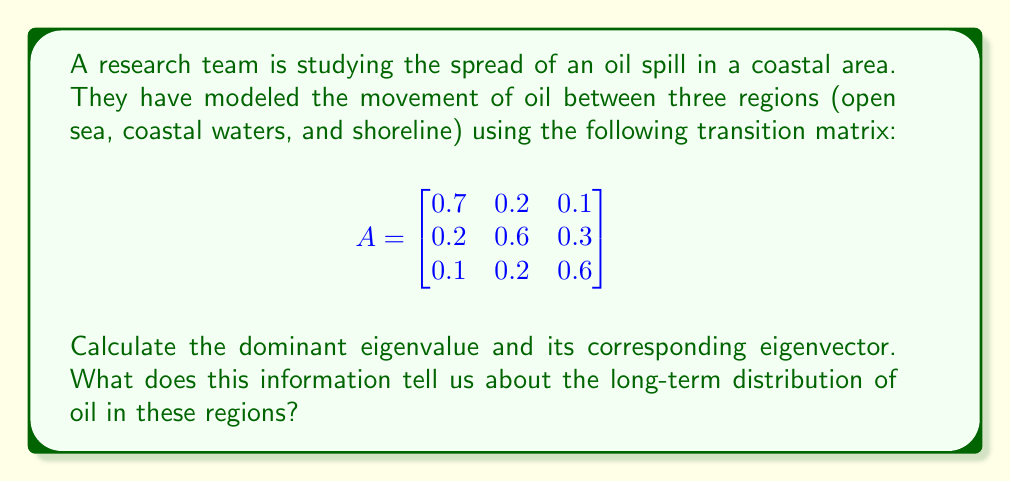Solve this math problem. To solve this problem, we need to follow these steps:

1) Find the characteristic equation:
   $$det(A - \lambda I) = 0$$
   
   $$\begin{vmatrix}
   0.7-\lambda & 0.2 & 0.1 \\
   0.2 & 0.6-\lambda & 0.3 \\
   0.1 & 0.2 & 0.6-\lambda
   \end{vmatrix} = 0$$

2) Expand the determinant:
   $$(0.7-\lambda)(0.6-\lambda)(0.6-\lambda) - 0.2 \cdot 0.3 \cdot 0.1 - 0.1 \cdot 0.2 \cdot 0.2 - (0.7-\lambda) \cdot 0.2 \cdot 0.2 - 0.2 \cdot (0.6-\lambda) \cdot 0.1 - 0.1 \cdot 0.3 \cdot (0.6-\lambda) = 0$$

3) Simplify:
   $$-\lambda^3 + 1.9\lambda^2 - 1.14\lambda + 0.216 = 0$$

4) Solve this cubic equation. The solutions are the eigenvalues. The largest eigenvalue is the dominant eigenvalue:
   $$\lambda_1 = 1, \lambda_2 \approx 0.5, \lambda_3 \approx 0.4$$

   The dominant eigenvalue is 1.

5) Find the eigenvector $v$ corresponding to $\lambda = 1$:
   $$(A - I)v = 0$$

   $$\begin{bmatrix}
   -0.3 & 0.2 & 0.1 \\
   0.2 & -0.4 & 0.3 \\
   0.1 & 0.2 & -0.4
   \end{bmatrix} \begin{bmatrix} v_1 \\ v_2 \\ v_3 \end{bmatrix} = \begin{bmatrix} 0 \\ 0 \\ 0 \end{bmatrix}$$

6) Solve this system of equations. One solution is:
   $$v = \begin{bmatrix} 2 \\ 3 \\ 3 \end{bmatrix}$$

7) Normalize the eigenvector:
   $$v_{normalized} = \frac{1}{\sqrt{2^2 + 3^2 + 3^2}} \begin{bmatrix} 2 \\ 3 \\ 3 \end{bmatrix} = \begin{bmatrix} 0.25 \\ 0.375 \\ 0.375 \end{bmatrix}$$

The dominant eigenvalue of 1 indicates that the system will reach a steady state in the long term. The corresponding normalized eigenvector represents the long-term distribution of oil in the three regions: 25% in the open sea, 37.5% in coastal waters, and 37.5% on the shoreline.
Answer: Dominant eigenvalue: 1
Corresponding normalized eigenvector: $\begin{bmatrix} 0.25 \\ 0.375 \\ 0.375 \end{bmatrix}$

This indicates that in the long term, 25% of the oil will be in the open sea, 37.5% in coastal waters, and 37.5% on the shoreline, regardless of the initial distribution. 